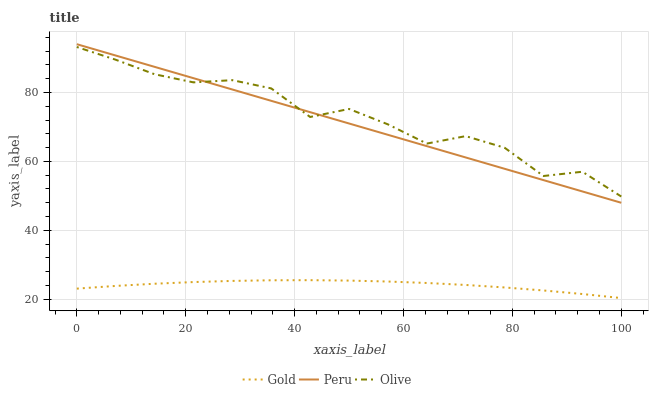Does Gold have the minimum area under the curve?
Answer yes or no. Yes. Does Olive have the maximum area under the curve?
Answer yes or no. Yes. Does Peru have the minimum area under the curve?
Answer yes or no. No. Does Peru have the maximum area under the curve?
Answer yes or no. No. Is Peru the smoothest?
Answer yes or no. Yes. Is Olive the roughest?
Answer yes or no. Yes. Is Gold the smoothest?
Answer yes or no. No. Is Gold the roughest?
Answer yes or no. No. Does Gold have the lowest value?
Answer yes or no. Yes. Does Peru have the lowest value?
Answer yes or no. No. Does Peru have the highest value?
Answer yes or no. Yes. Does Gold have the highest value?
Answer yes or no. No. Is Gold less than Olive?
Answer yes or no. Yes. Is Olive greater than Gold?
Answer yes or no. Yes. Does Olive intersect Peru?
Answer yes or no. Yes. Is Olive less than Peru?
Answer yes or no. No. Is Olive greater than Peru?
Answer yes or no. No. Does Gold intersect Olive?
Answer yes or no. No. 